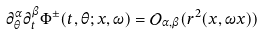Convert formula to latex. <formula><loc_0><loc_0><loc_500><loc_500>\partial _ { \theta } ^ { \alpha } \partial _ { t } ^ { \beta } \Phi ^ { \pm } ( t , \theta ; x , \omega ) = { \mathcal { O } } _ { \alpha , \beta } ( r ^ { 2 } ( x , \omega x ) )</formula> 